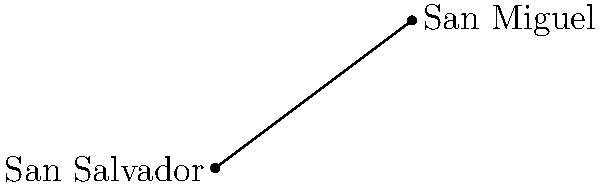As a Political Analyst specialized in El Salvador's political landscape, you're studying the geographic distribution of voter demographics. You need to calculate the straight-line distance between San Salvador and San Miguel for a voter outreach program. Given that San Salvador is located at coordinates (0,0) and San Miguel at (80,60) on a map where each unit represents 1 km, what is the distance between these two cities? Use the distance formula and round your answer to the nearest kilometer. To solve this problem, we'll use the distance formula derived from the Pythagorean theorem:

$$d = \sqrt{(x_2-x_1)^2 + (y_2-y_1)^2}$$

Where:
$(x_1,y_1)$ is the coordinate of San Salvador (0,0)
$(x_2,y_2)$ is the coordinate of San Miguel (80,60)

Step 1: Substitute the values into the formula:
$$d = \sqrt{(80-0)^2 + (60-0)^2}$$

Step 2: Simplify inside the parentheses:
$$d = \sqrt{80^2 + 60^2}$$

Step 3: Calculate the squares:
$$d = \sqrt{6400 + 3600}$$

Step 4: Add the values under the square root:
$$d = \sqrt{10000}$$

Step 5: Calculate the square root:
$$d = 100$$

Therefore, the distance between San Salvador and San Miguel is 100 km.
Answer: 100 km 